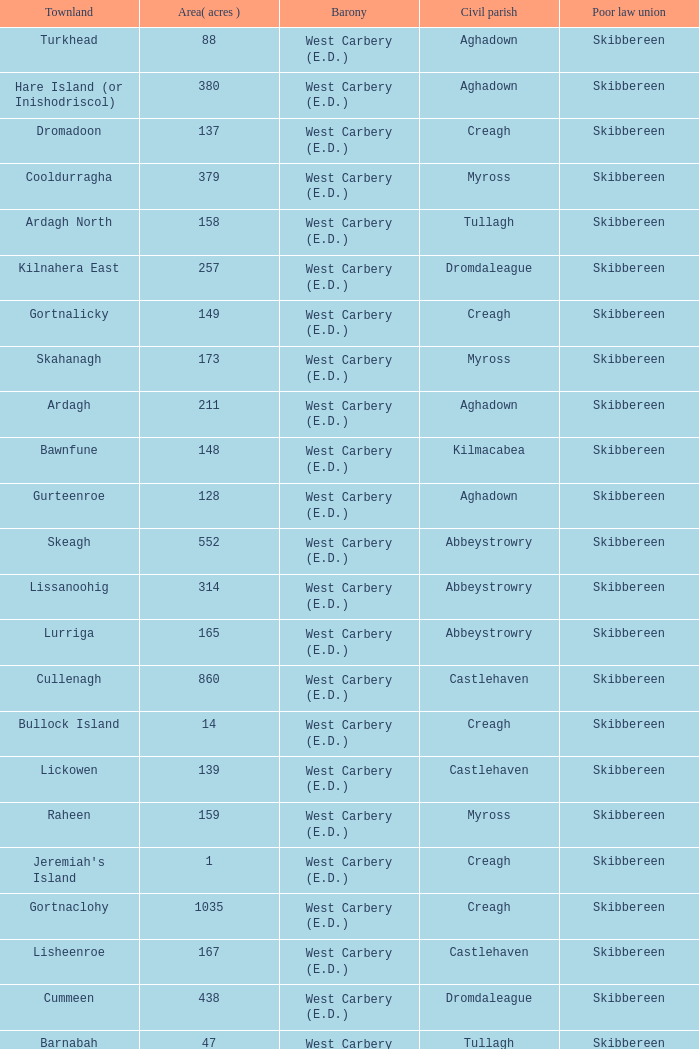What is the greatest area when the Poor Law Union is Skibbereen and the Civil Parish is Tullagh? 796.0. 